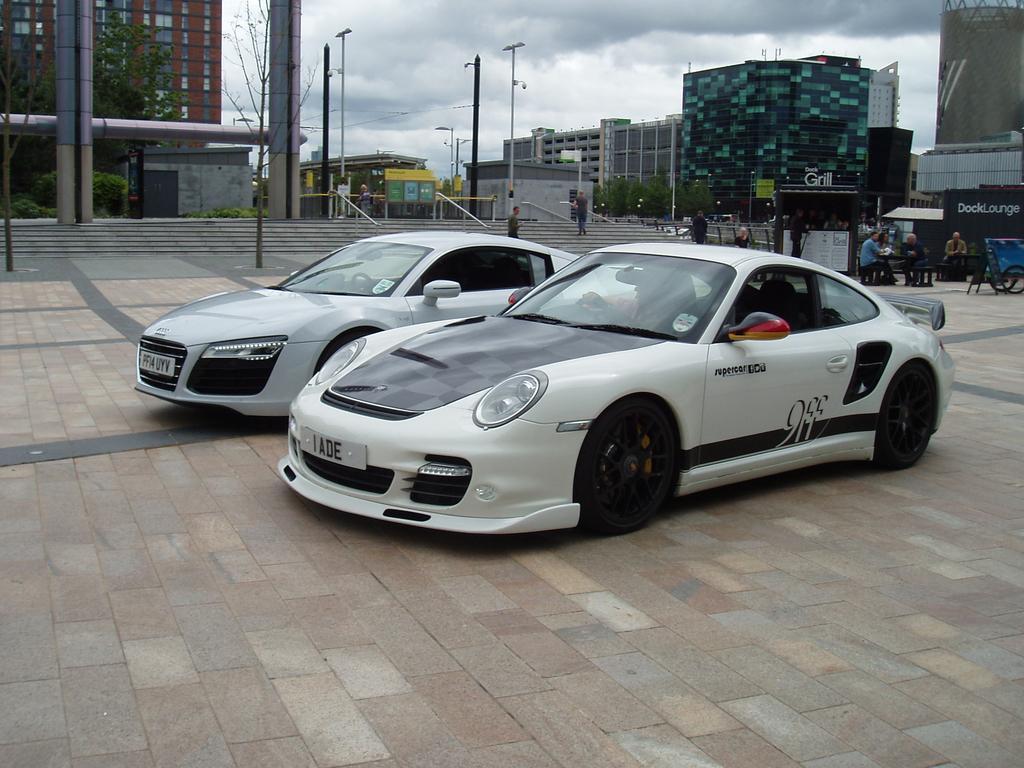In one or two sentences, can you explain what this image depicts? In this picture we can see cars on the ground, cart and shop. There are people and we can see steps, railings, poles, lights, trees and buildings. In the background of the image we can see the sky with clouds. 